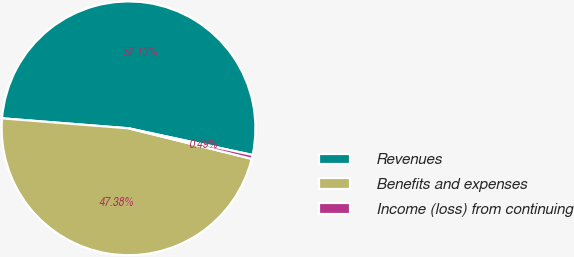Convert chart. <chart><loc_0><loc_0><loc_500><loc_500><pie_chart><fcel>Revenues<fcel>Benefits and expenses<fcel>Income (loss) from continuing<nl><fcel>52.12%<fcel>47.38%<fcel>0.49%<nl></chart> 